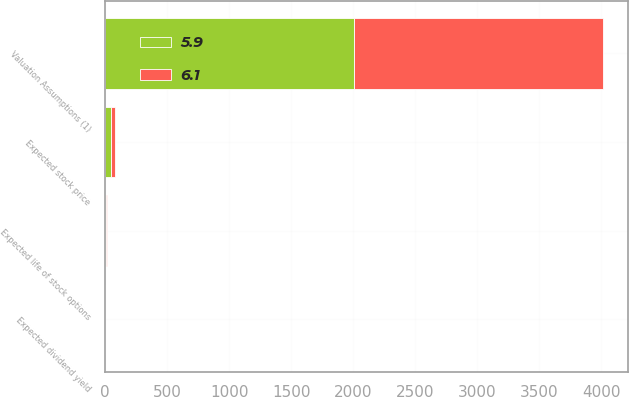<chart> <loc_0><loc_0><loc_500><loc_500><stacked_bar_chart><ecel><fcel>Valuation Assumptions (1)<fcel>Expected dividend yield<fcel>Expected stock price<fcel>Expected life of stock options<nl><fcel>5.9<fcel>2009<fcel>1.6<fcel>45<fcel>6.1<nl><fcel>6.1<fcel>2008<fcel>1.1<fcel>33<fcel>5.9<nl></chart> 